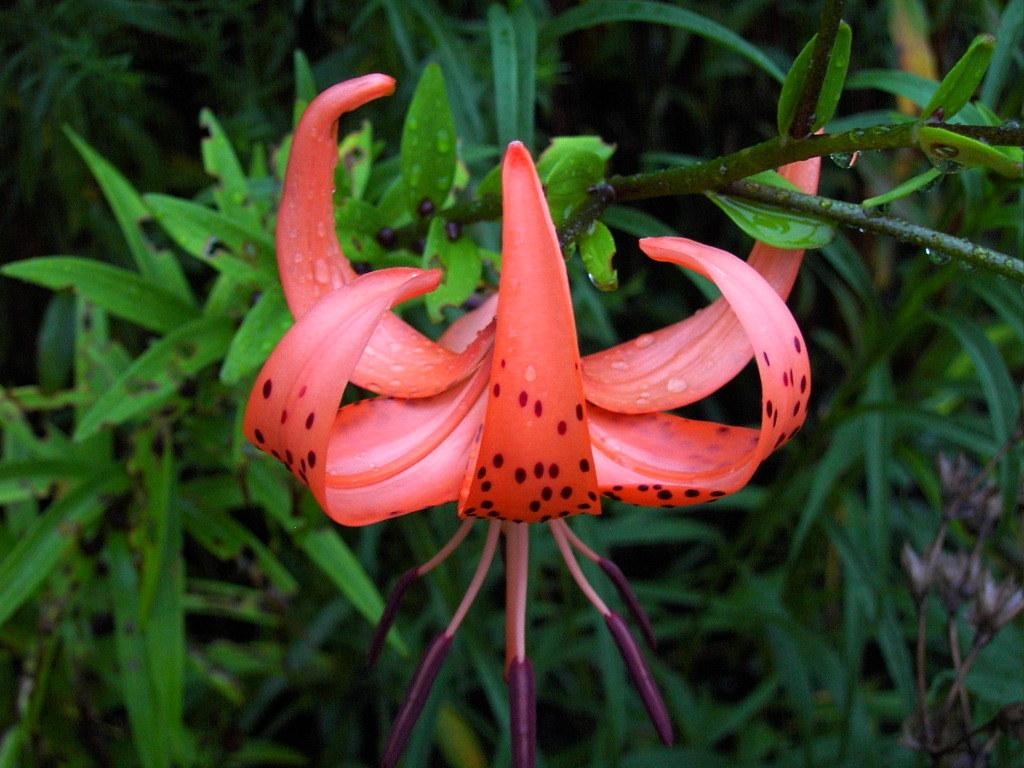What type of plant can be seen in the image? There is a flower in the image. What else is present in the image besides the flower? There are leaves in the image. What type of grass is growing in a circle around the flower in the image? There is no grass present in the image, and the flower is not surrounded by a circle. 